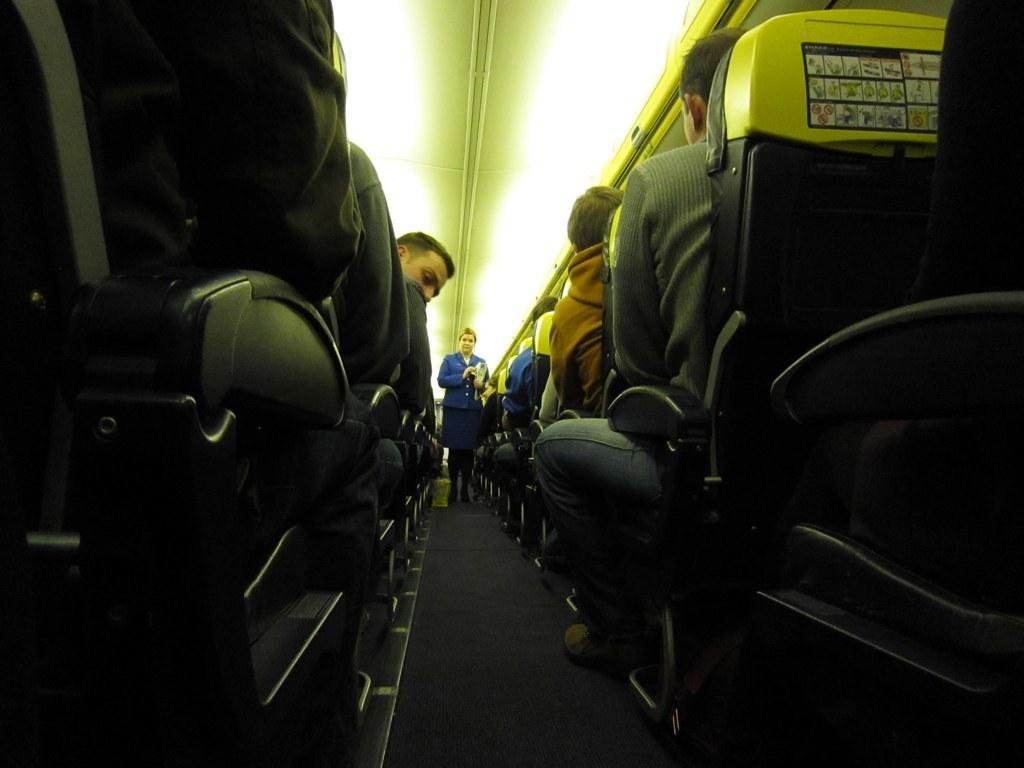What is happening on the left side of the side of the image? There are people sitting on chairs on the left side of the image. What is happening on the right side of the side of the image? There are people sitting on chairs on the right side of the image. What is the woman in the middle of the image doing? There is a woman standing in the middle of the image. What type of silver item is the woman wearing around her neck in the image? There is no silver item mentioned or visible around the woman's neck in the image. Is there a scarf draped over any of the chairs in the image? The provided facts do not mention or show any scarves in the image. 